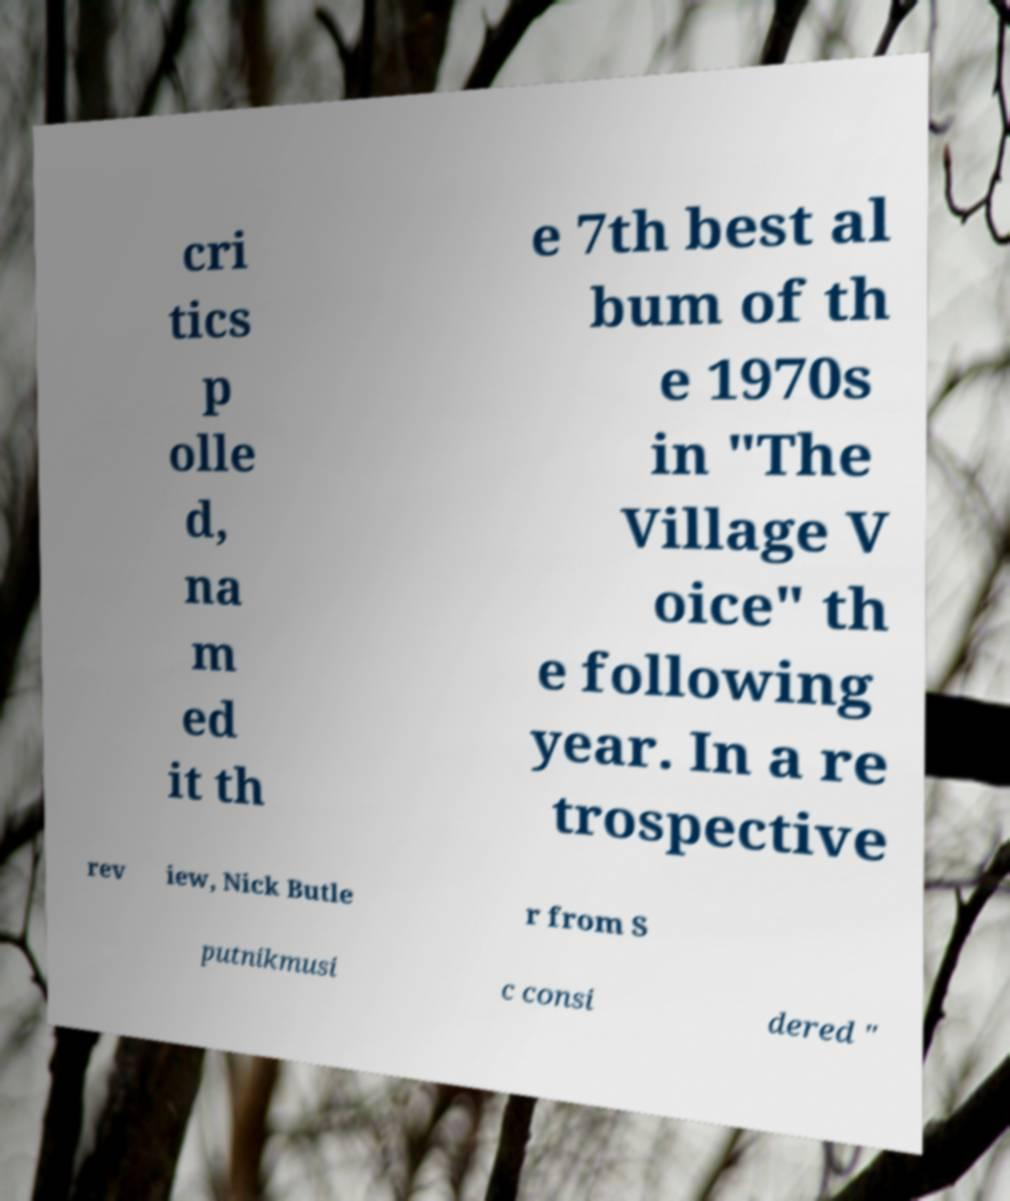Could you extract and type out the text from this image? cri tics p olle d, na m ed it th e 7th best al bum of th e 1970s in "The Village V oice" th e following year. In a re trospective rev iew, Nick Butle r from S putnikmusi c consi dered " 